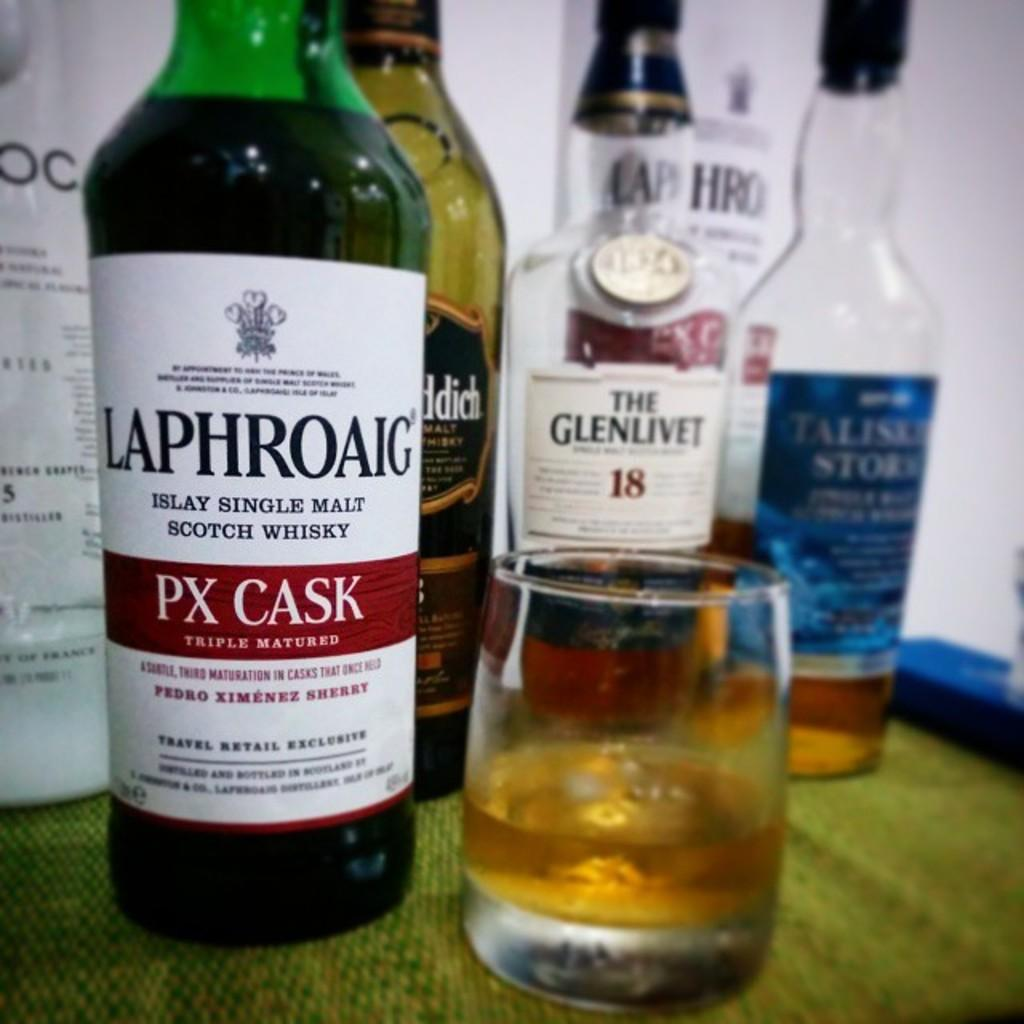Provide a one-sentence caption for the provided image. A glass of whiskey sits next to a bottle of Laphroaig. 